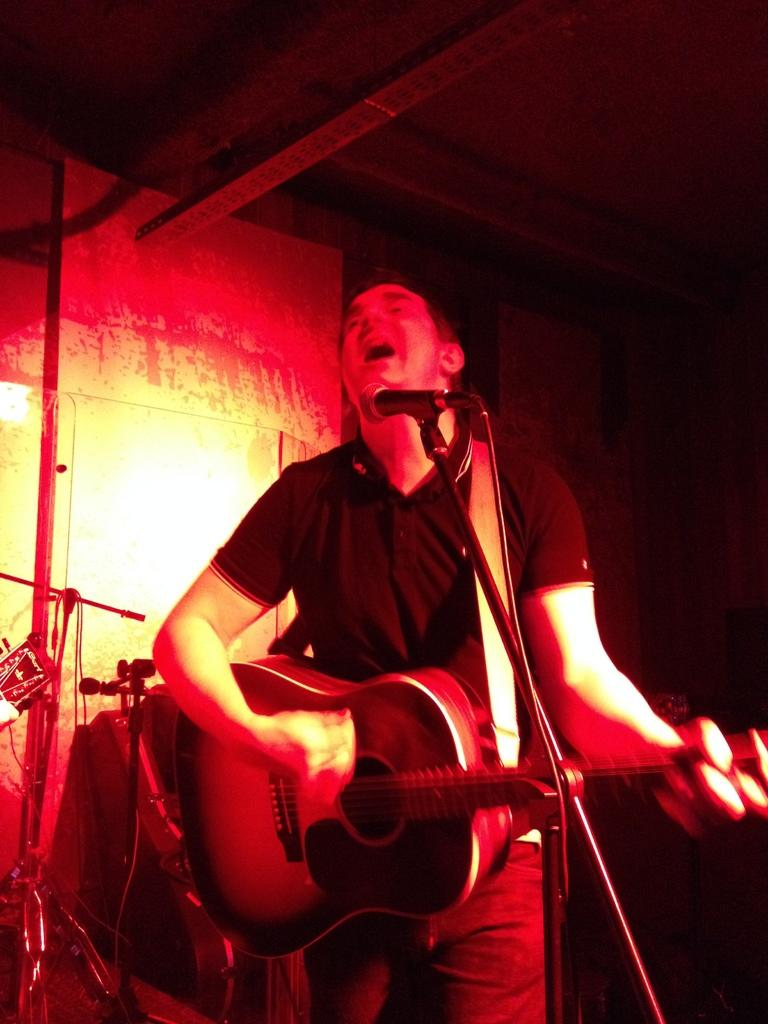What is present in the image? There is a man in the image. What is the man holding in his hand? The man is holding a guitar in his hand. How many pigs can be seen fighting in the image? There are no pigs present in the image, nor are there any fights depicted. What is the name of the man in the image? The provided facts do not include the name of the man in the image. 